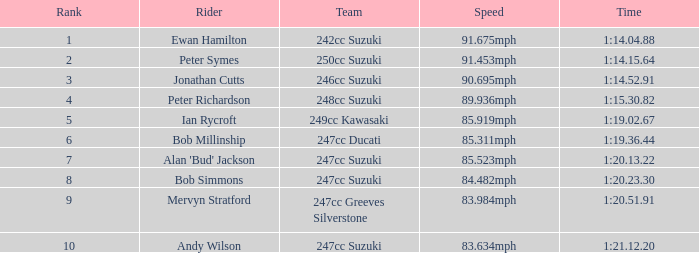1 91.453mph. 